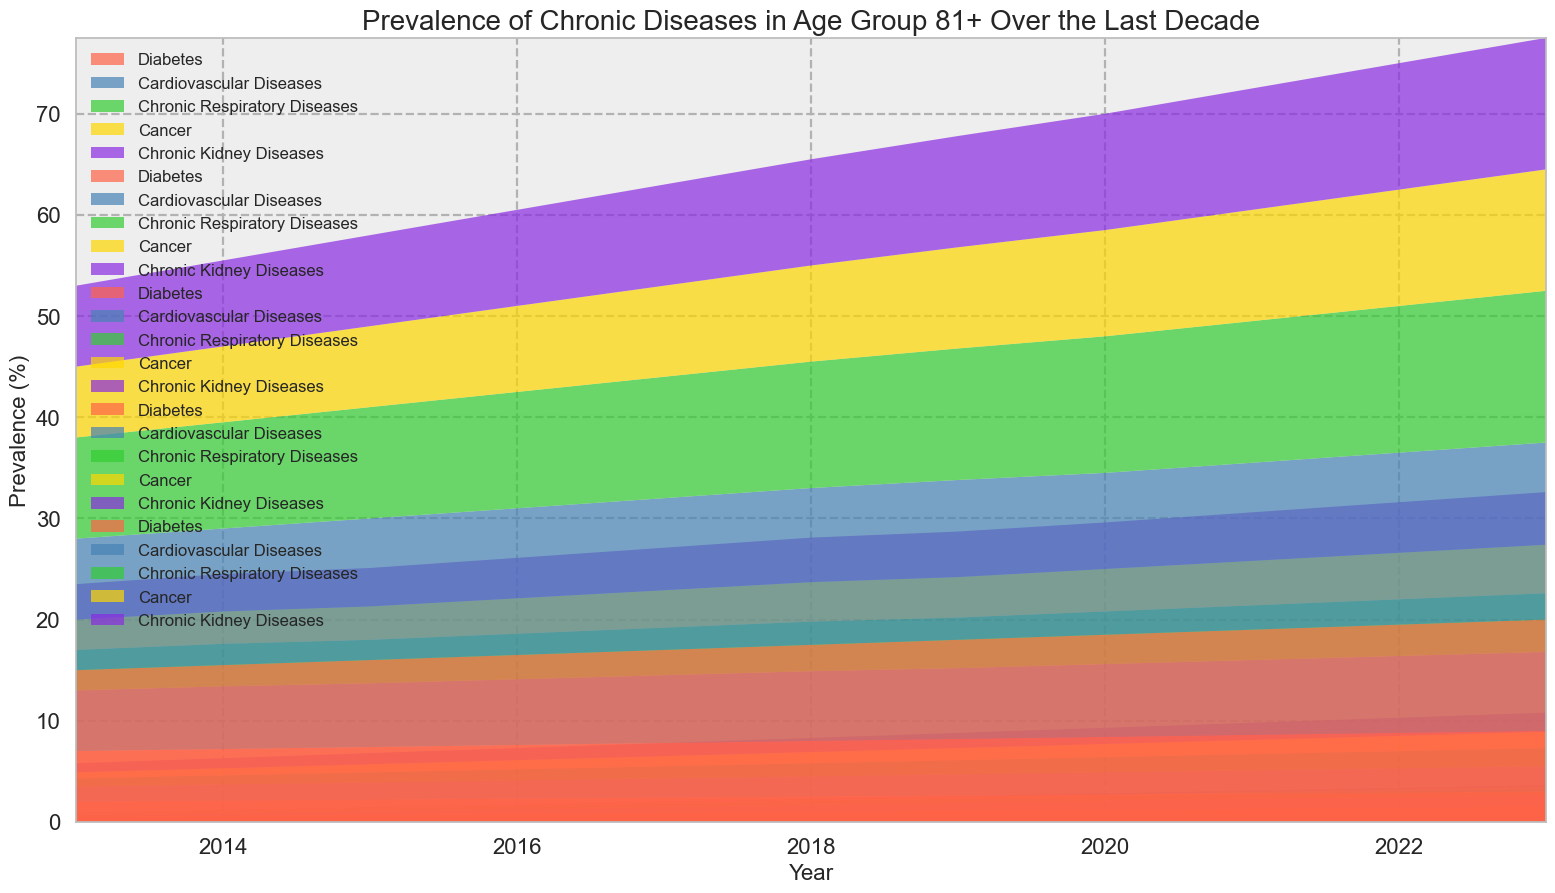What age group has the highest prevalence of diabetes in 2023? In the 2023 chart, we look at each age group and find the area with the highest height for diabetes, which is the red section representing diabetes. The "81+" age group has the highest diabetes prevalence.
Answer: 81+ Which disease shows the greatest increase in prevalence in the 61-80 age group from 2013 to 2023? For the age group 61-80, we compare each disease's prevalence in 2013 and 2023 by observing the height of their respective areas over time. Diabetes shows an increase from 7.0% to 9.0%, which is the greatest change.
Answer: Diabetes What was the prevalence of chronic respiratory diseases in the 21-40 age group in 2017? In the chart for 2017, we find the blue area representing chronic respiratory diseases for the 21-40 age group. The prevalence is at 0.3%.
Answer: 0.3% Compare the prevalence of cancer between the age groups 41-60 and 81+ in 2022. Which is higher? In the 2022 chart, the height of the green area representing cancer in both the 41-60 and 81+ age groups is compared. The 81+ age group shows a higher prevalence at 11.5% compared to 1.5% in the 41-60 age group.
Answer: 81+ What is the average prevalence of cardiovascular diseases in the 41-60 age group over the decade? To find the average, we sum the prevalence of cardiovascular diseases for each year from 2013 to 2023 in the 41-60 age group (1.5 + 1.6 + 1.7 + 1.8 + 1.9 + 2.0 + 2.1 + 2.2 + 2.3 + 2.4 + 2.5) and divide by the number of years (11): (22.0/11) = 2.0%.
Answer: 2.0% Is the prevalence of chronic kidney diseases higher in the 61-80 age group or the 81+ age group in 2020? In the 2020 chart, we compare the length of the purple area for chronic kidney diseases in both age groups. The 81+ age group has a higher prevalence of 11.5% compared to 4.6% in the 61-80 age group.
Answer: 81+ What is the trend of diabetes prevalence in the 0-20 age group over the last decade? Observing the charts for the 0-20 age group from 2013 to 2023, the red area representing diabetes prevalence remains constant at 0.1% throughout the decade, indicating no change.
Answer: Constant (0.1%) How does the prevalence of chronic respiratory diseases in the 21-40 age group in 2013 compare to its prevalence in 2023? Comparing the 2013 and 2023 charts, the height of the green area for chronic respiratory diseases in the 21-40 age group increases from 0.1% to 0.6%.
Answer: Increased (from 0.1% to 0.6%) What is the sum of the prevalences of all diseases in the 81+ age group in 2015? To find the sum, we add the prevalence of each disease for the 81+ age group in 2015: (16.0 + 14.0 + 11.0 + 8.0 + 9.0) = 58.0%.
Answer: 58.0% 